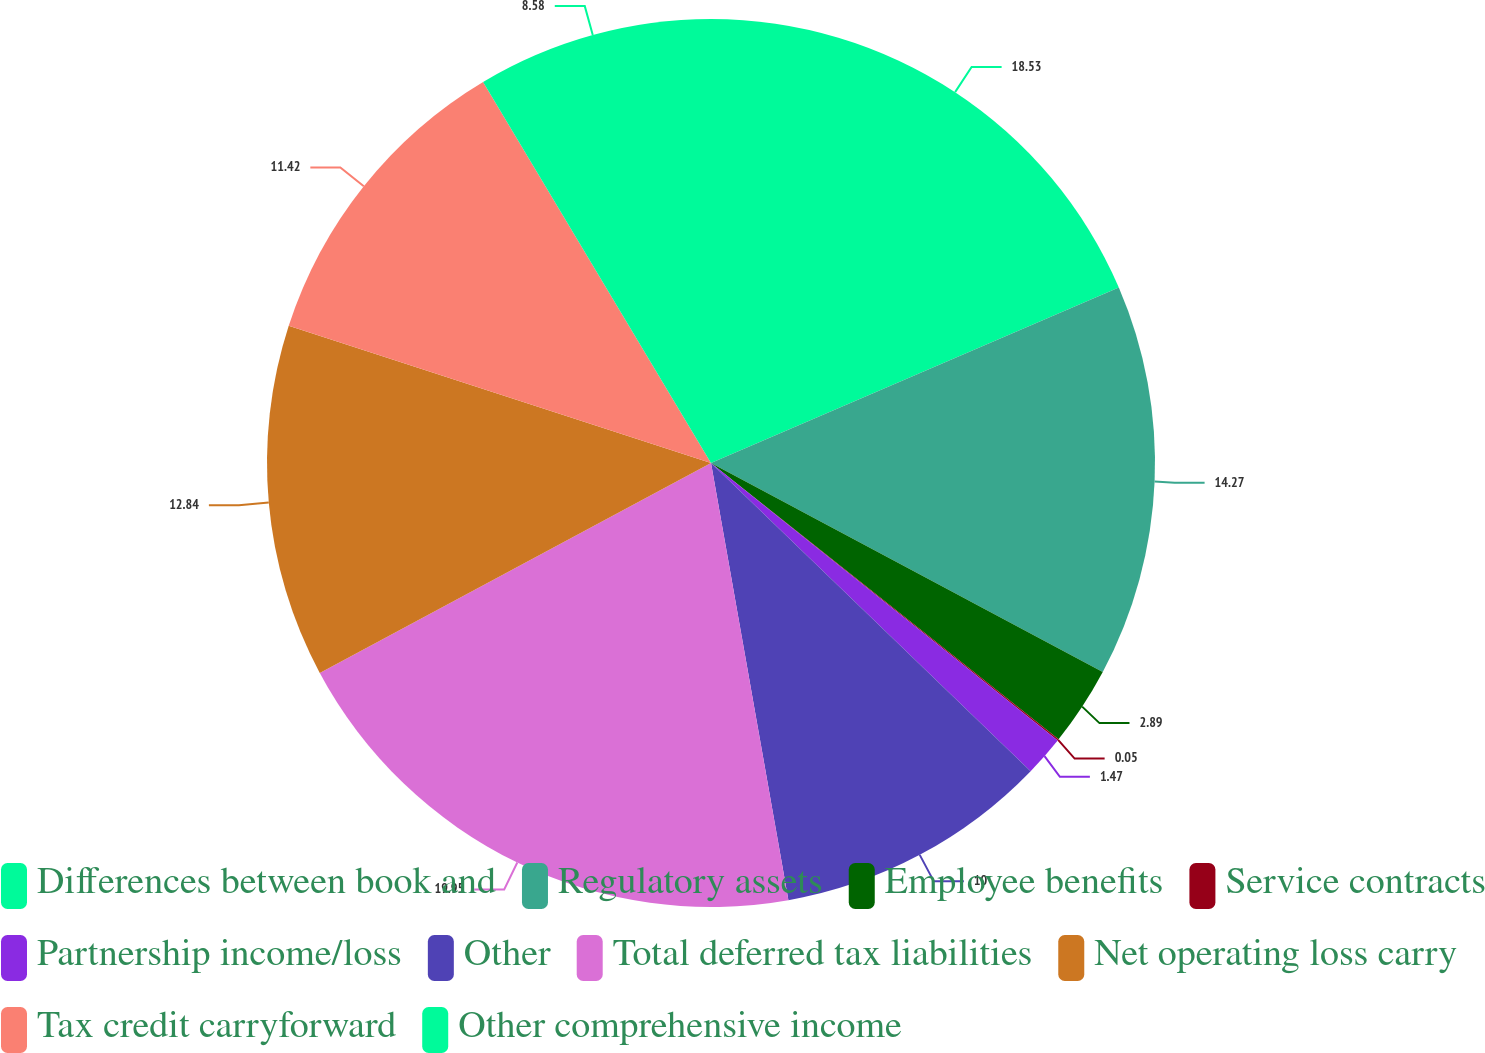Convert chart. <chart><loc_0><loc_0><loc_500><loc_500><pie_chart><fcel>Differences between book and<fcel>Regulatory assets<fcel>Employee benefits<fcel>Service contracts<fcel>Partnership income/loss<fcel>Other<fcel>Total deferred tax liabilities<fcel>Net operating loss carry<fcel>Tax credit carryforward<fcel>Other comprehensive income<nl><fcel>18.53%<fcel>14.27%<fcel>2.89%<fcel>0.05%<fcel>1.47%<fcel>10.0%<fcel>19.95%<fcel>12.84%<fcel>11.42%<fcel>8.58%<nl></chart> 